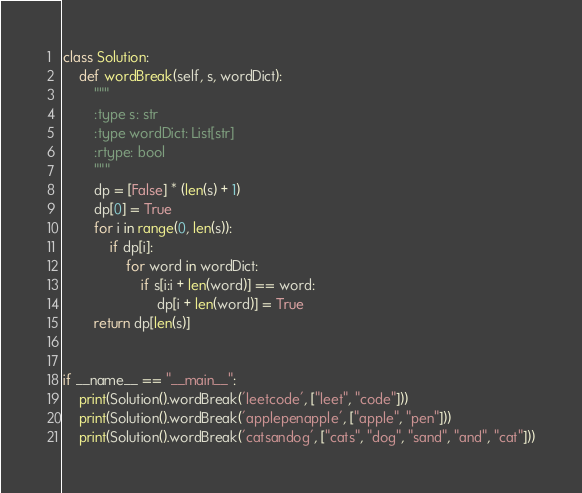Convert code to text. <code><loc_0><loc_0><loc_500><loc_500><_Python_>class Solution:
    def wordBreak(self, s, wordDict):
        """
        :type s: str
        :type wordDict: List[str]
        :rtype: bool
        """
        dp = [False] * (len(s) + 1)
        dp[0] = True
        for i in range(0, len(s)):
            if dp[i]:
                for word in wordDict:
                    if s[i:i + len(word)] == word:
                        dp[i + len(word)] = True
        return dp[len(s)]


if __name__ == "__main__":
    print(Solution().wordBreak('leetcode', ["leet", "code"]))
    print(Solution().wordBreak('applepenapple', ["apple", "pen"]))
    print(Solution().wordBreak('catsandog', ["cats", "dog", "sand", "and", "cat"]))</code> 